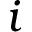<formula> <loc_0><loc_0><loc_500><loc_500>i</formula> 